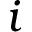<formula> <loc_0><loc_0><loc_500><loc_500>i</formula> 